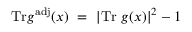<formula> <loc_0><loc_0><loc_500><loc_500>T r g ^ { a d j } ( x ) = \left | T r g ( x ) \right | ^ { 2 } - 1</formula> 